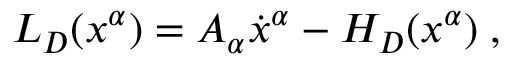<formula> <loc_0><loc_0><loc_500><loc_500>L _ { D } ( x ^ { \alpha } ) = A _ { \alpha } \dot { x } ^ { \alpha } - H _ { D } ( x ^ { \alpha } ) \, ,</formula> 